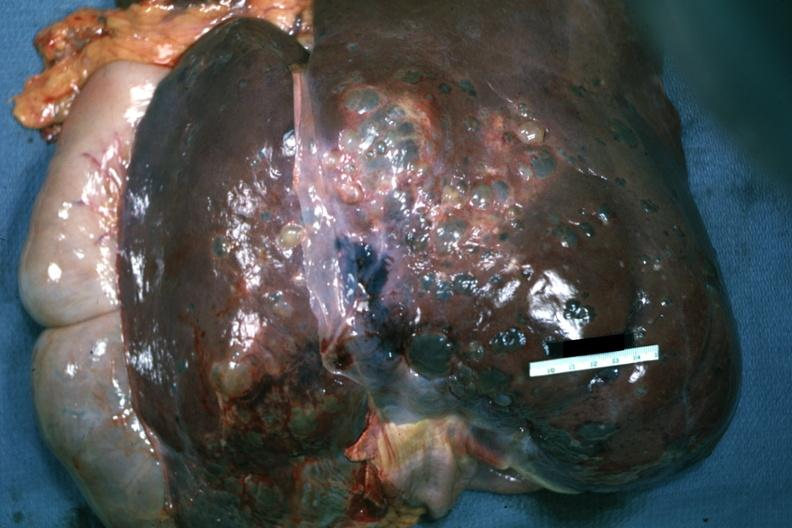what is present?
Answer the question using a single word or phrase. Liver 